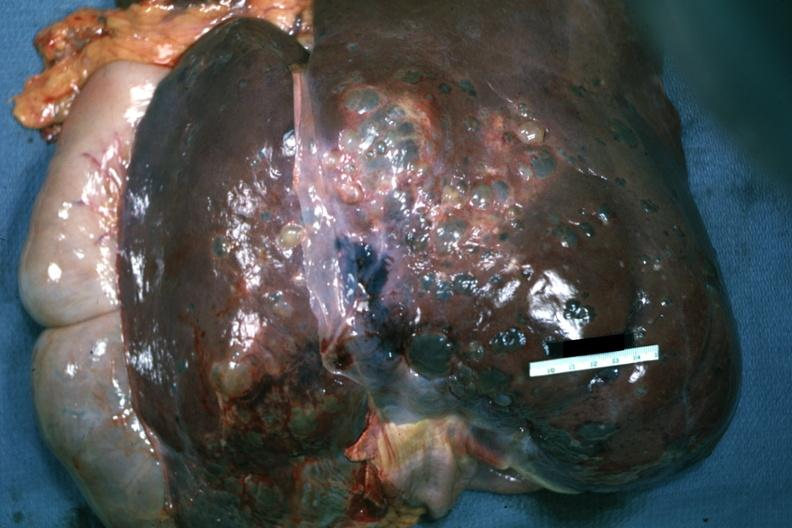what is present?
Answer the question using a single word or phrase. Liver 